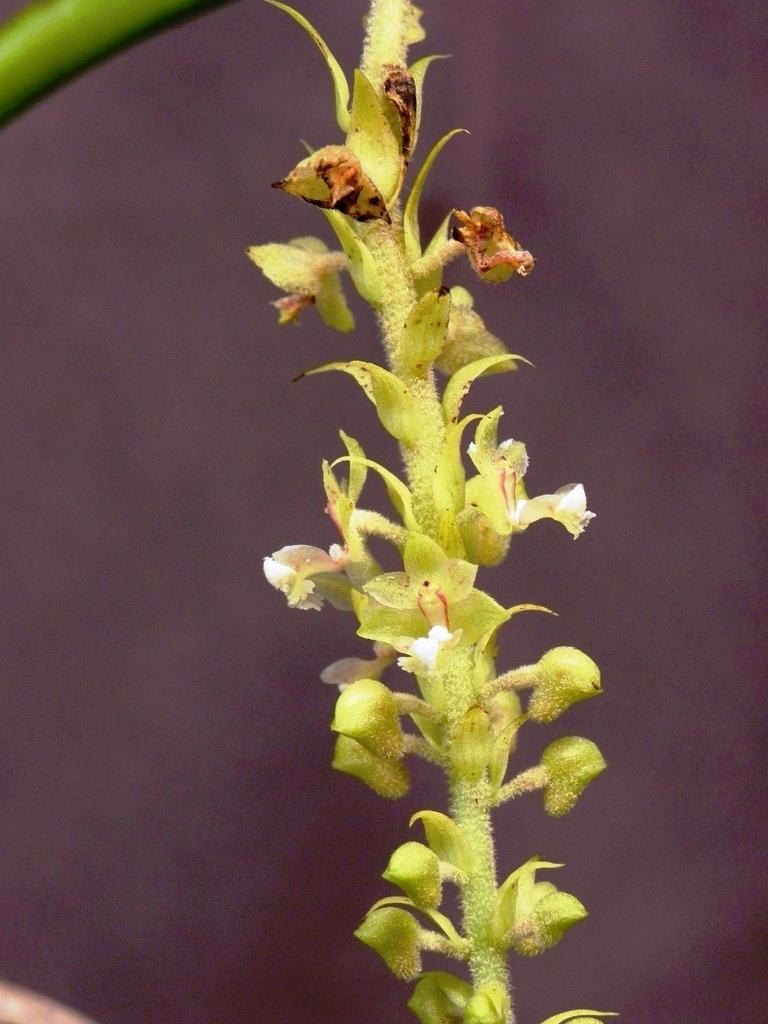What is the main subject of the image? The main subject of the image is a stem with flowers. What color are the flowers? The flowers are white in color. Can you describe the background of the image? The background of the image is blurred. How many members are on the team in the image? There is no team present in the image; it features a stem with white flowers and a blurred background. What is the chance of rain in the image? There is no indication of weather or rain in the image, as it focuses on a stem with white flowers and a blurred background. 